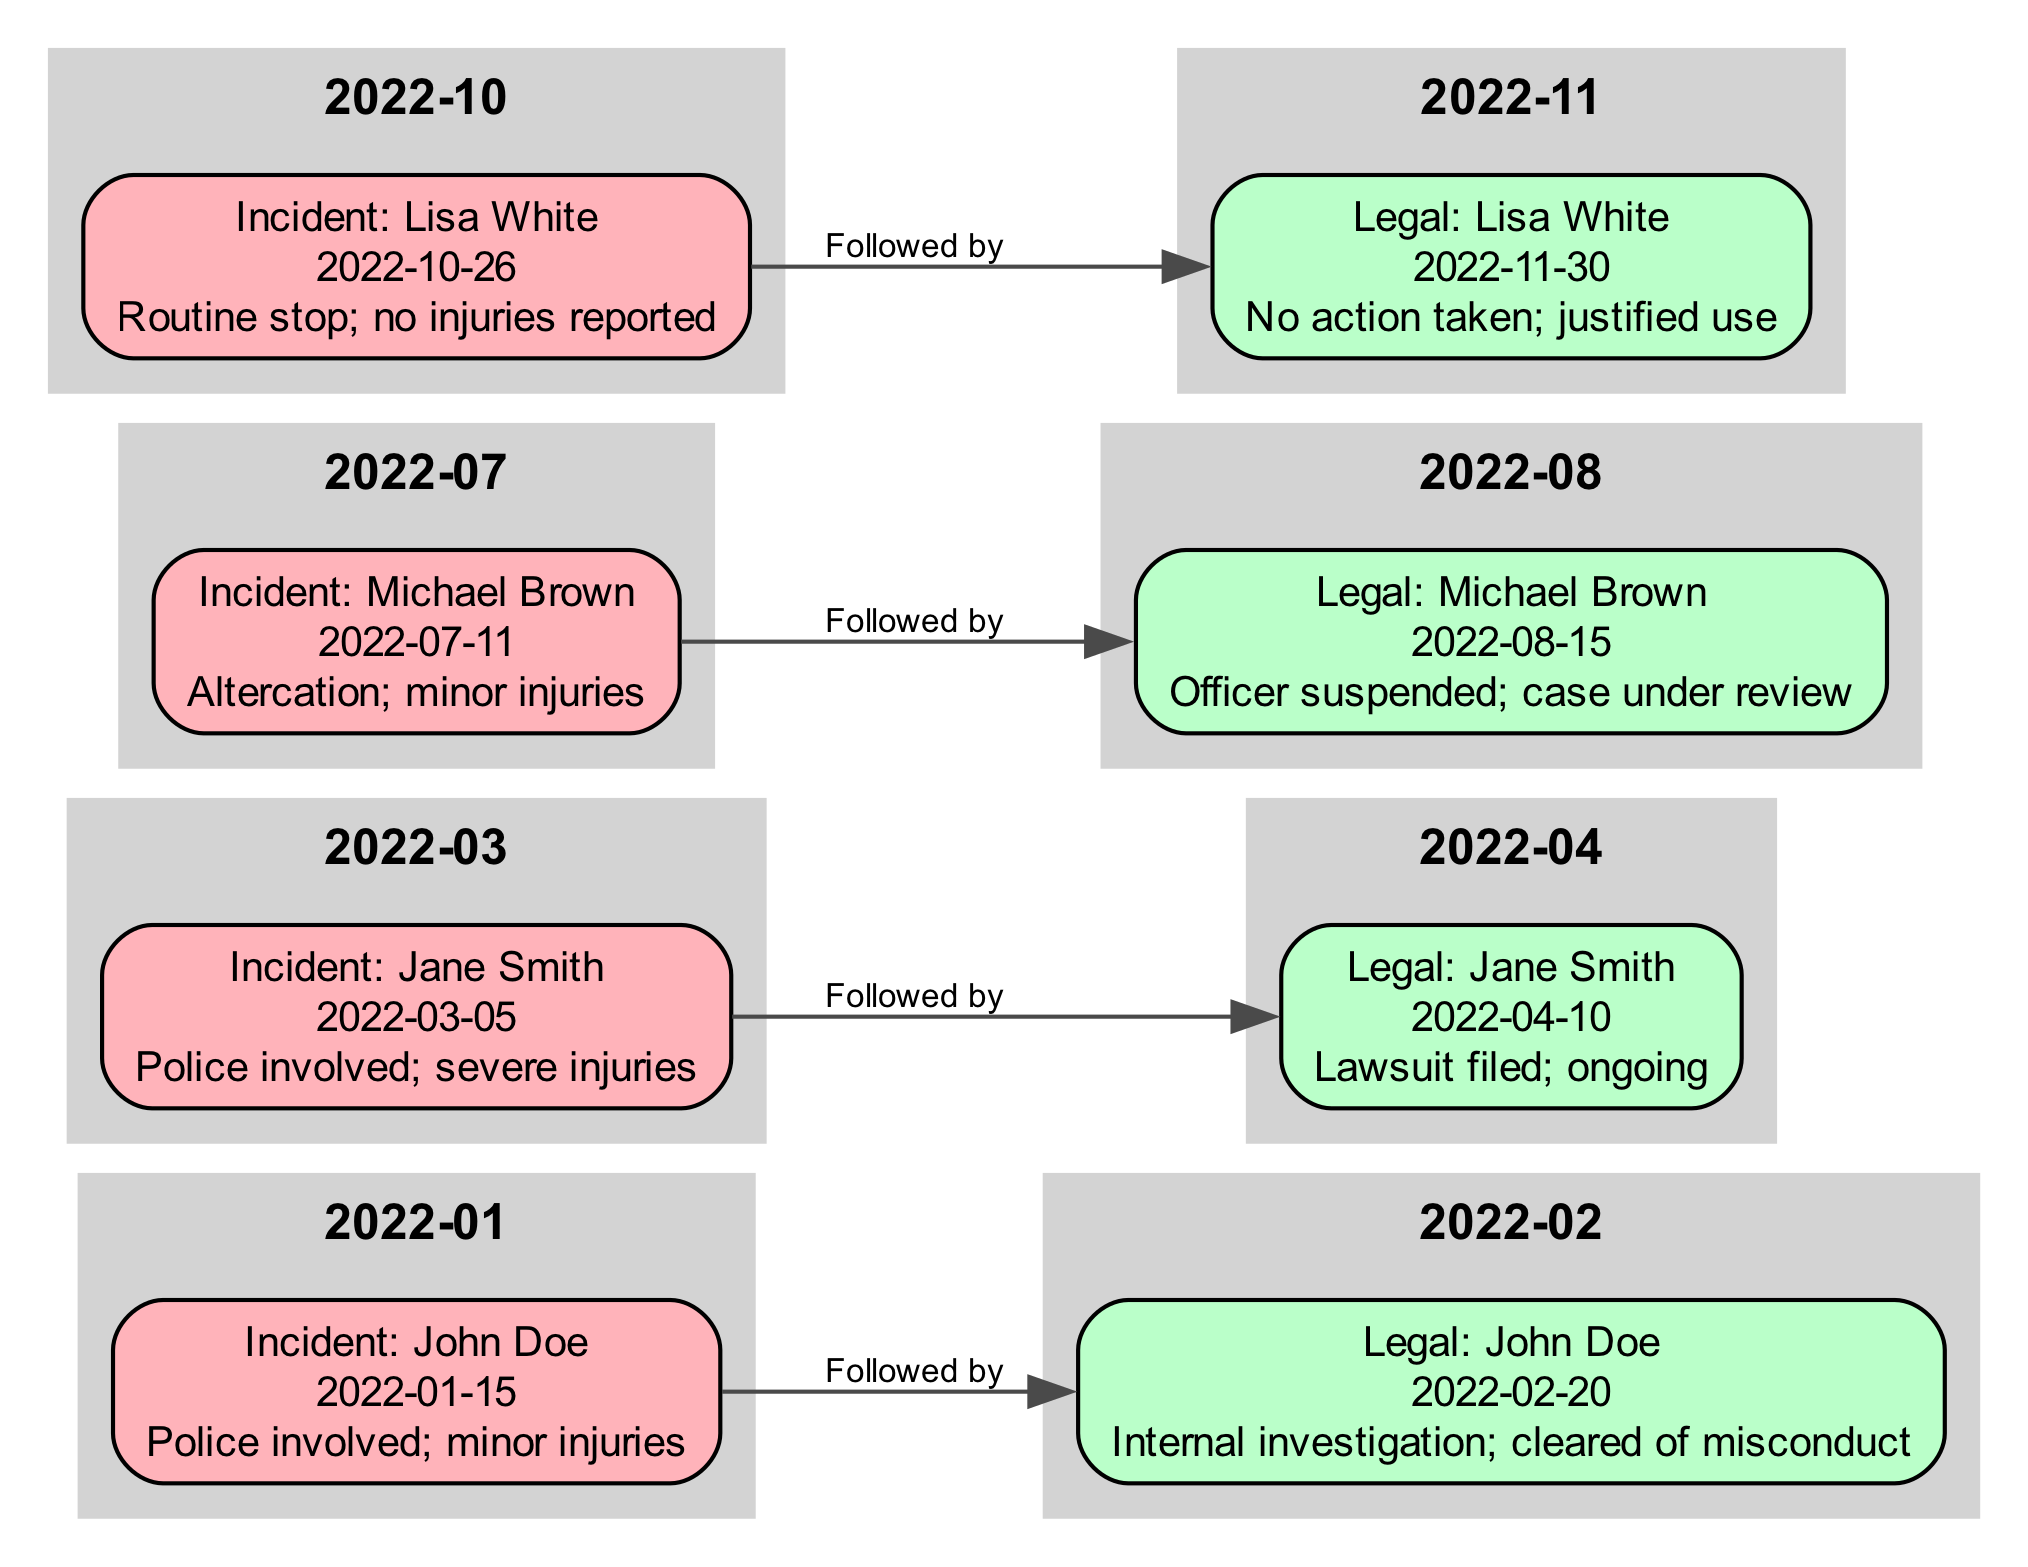What is the date of the incident involving John Doe? The diagram shows that the incident labeled "Incident: John Doe" occurred on "2022-01-15". This can be found by locating the node corresponding to John Doe and reading the date information provided.
Answer: 2022-01-15 How many incidents are recorded in the timeline? By counting the nodes labeled as incidents in the diagram, we find there are four nodes with labels starting with "Incident". Thus, the total number of incidents is four.
Answer: 4 What was the legal outcome for Lisa White? The node labeled "Legal: Lisa White" indicates "No action taken; justified use". This conclusion is derived from the details written directly under the legal proceedings node associated with Lisa White.
Answer: No action taken; justified use Which incident had severe injuries reported? The diagram indicates "Incident: Jane Smith" with the detail "severe injuries". This can be identified by examining the incident nodes for descriptions that mention severe injuries.
Answer: Incident: Jane Smith What legal proceeding is associated with Michael Brown's incident? The diagram connects the incident "Incident: Michael Brown" to its respective legal proceeding labeled "Legal: Michael Brown". The relationship shows an edge indicating that the legal action that followed this incident involved suspension of the officer and is under review.
Answer: Officer suspended; case under review How many legal proceedings resulted in an internal investigation? From the timeline, only the node "Legal: John Doe" mentions an "internal investigation; cleared of misconduct". By reviewing the legal proceedings nodes, we can identify that there is only one such case.
Answer: 1 What incident occurred after Jane Smith's incident? Referring to the order of the timeline, the incident that follows "Incident: Jane Smith" is "Incident: Michael Brown". This can be concluded by following the sequence of nodes in the diagram.
Answer: Incident: Michael Brown Which incident had no injuries reported? The diagram specifies "Incident: Lisa White" with details stating "no injuries reported". This information can be retrieved by checking the incident nodes for those that mention no injuries.
Answer: Incident: Lisa White What type of investigation was related to the incident involving John Doe? The associated legal proceeding for "Incident: John Doe" describes an "internal investigation; cleared of misconduct". The details of the legal node connected to John Doe inform this answer.
Answer: Internal investigation 